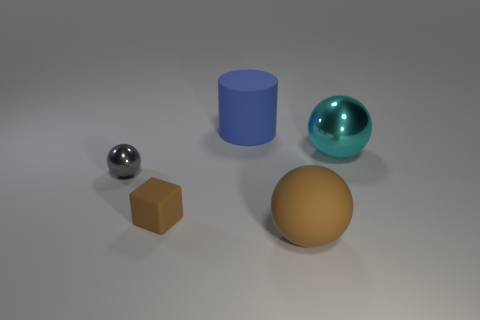Add 5 green metallic objects. How many objects exist? 10 Subtract all blocks. How many objects are left? 4 Subtract all tiny matte objects. Subtract all tiny brown rubber objects. How many objects are left? 3 Add 3 tiny gray shiny objects. How many tiny gray shiny objects are left? 4 Add 3 tiny rubber blocks. How many tiny rubber blocks exist? 4 Subtract 0 yellow cubes. How many objects are left? 5 